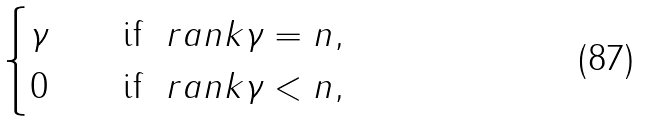Convert formula to latex. <formula><loc_0><loc_0><loc_500><loc_500>\begin{cases} \gamma \quad & \text {if} \ \ r a n k \gamma = n , \\ 0 \quad & \text {if} \ \ r a n k \gamma < n , \end{cases}</formula> 